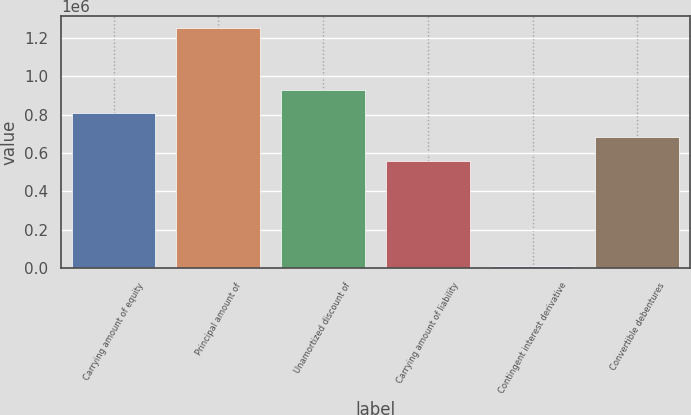Convert chart. <chart><loc_0><loc_0><loc_500><loc_500><bar_chart><fcel>Carrying amount of equity<fcel>Principal amount of<fcel>Unamortized discount of<fcel>Carrying amount of liability<fcel>Contingent interest derivative<fcel>Convertible debentures<nl><fcel>806053<fcel>1.25e+06<fcel>929998<fcel>558163<fcel>10549<fcel>682108<nl></chart> 